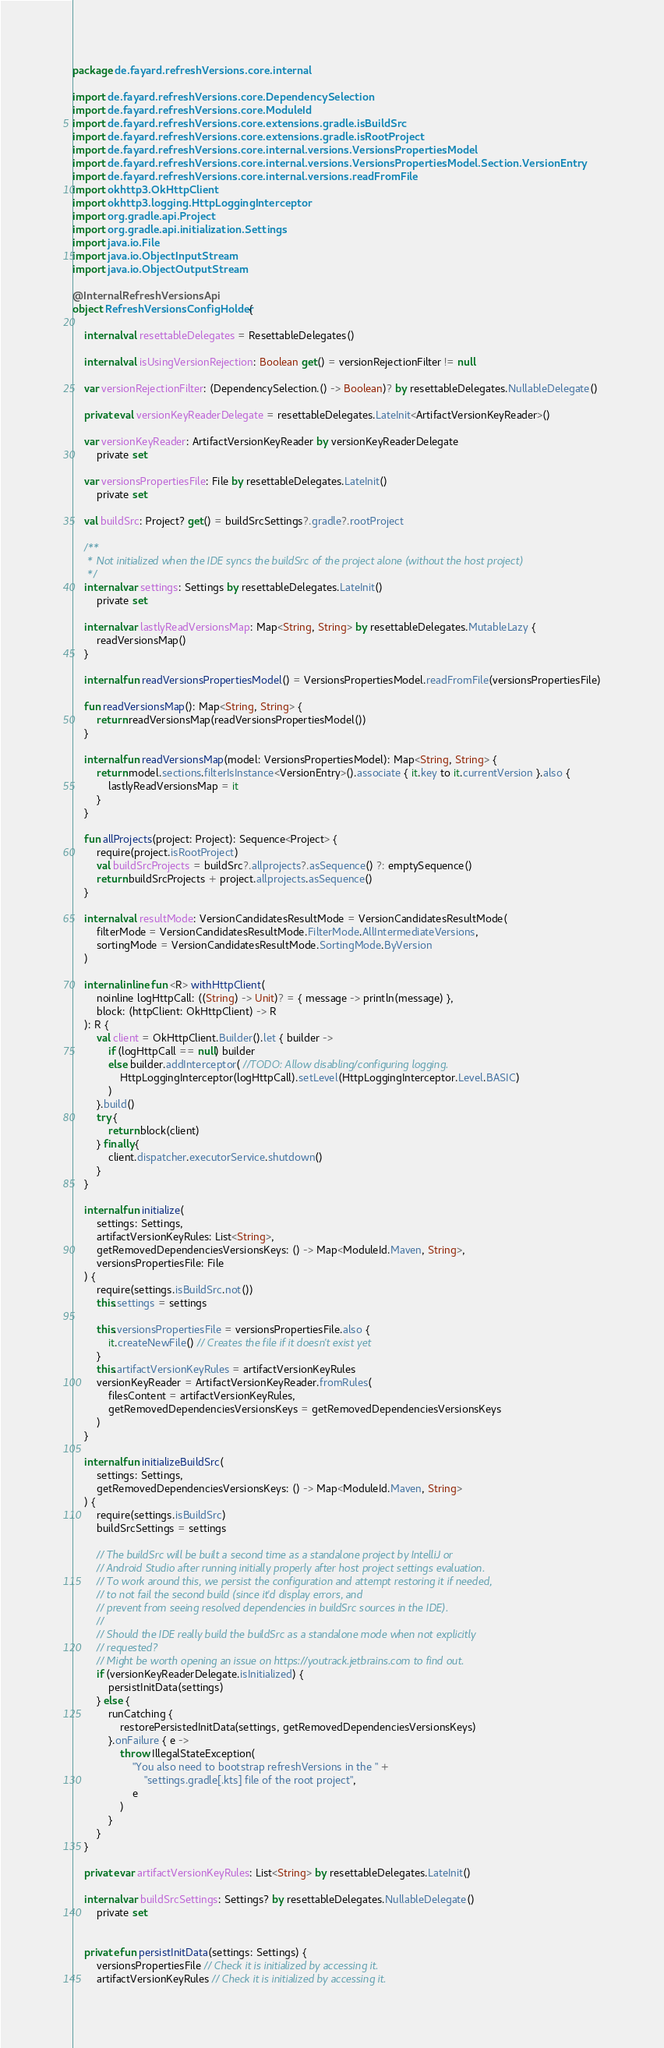<code> <loc_0><loc_0><loc_500><loc_500><_Kotlin_>package de.fayard.refreshVersions.core.internal

import de.fayard.refreshVersions.core.DependencySelection
import de.fayard.refreshVersions.core.ModuleId
import de.fayard.refreshVersions.core.extensions.gradle.isBuildSrc
import de.fayard.refreshVersions.core.extensions.gradle.isRootProject
import de.fayard.refreshVersions.core.internal.versions.VersionsPropertiesModel
import de.fayard.refreshVersions.core.internal.versions.VersionsPropertiesModel.Section.VersionEntry
import de.fayard.refreshVersions.core.internal.versions.readFromFile
import okhttp3.OkHttpClient
import okhttp3.logging.HttpLoggingInterceptor
import org.gradle.api.Project
import org.gradle.api.initialization.Settings
import java.io.File
import java.io.ObjectInputStream
import java.io.ObjectOutputStream

@InternalRefreshVersionsApi
object RefreshVersionsConfigHolder {

    internal val resettableDelegates = ResettableDelegates()

    internal val isUsingVersionRejection: Boolean get() = versionRejectionFilter != null

    var versionRejectionFilter: (DependencySelection.() -> Boolean)? by resettableDelegates.NullableDelegate()

    private val versionKeyReaderDelegate = resettableDelegates.LateInit<ArtifactVersionKeyReader>()

    var versionKeyReader: ArtifactVersionKeyReader by versionKeyReaderDelegate
        private set

    var versionsPropertiesFile: File by resettableDelegates.LateInit()
        private set

    val buildSrc: Project? get() = buildSrcSettings?.gradle?.rootProject

    /**
     * Not initialized when the IDE syncs the buildSrc of the project alone (without the host project)
     */
    internal var settings: Settings by resettableDelegates.LateInit()
        private set

    internal var lastlyReadVersionsMap: Map<String, String> by resettableDelegates.MutableLazy {
        readVersionsMap()
    }

    internal fun readVersionsPropertiesModel() = VersionsPropertiesModel.readFromFile(versionsPropertiesFile)

    fun readVersionsMap(): Map<String, String> {
        return readVersionsMap(readVersionsPropertiesModel())
    }

    internal fun readVersionsMap(model: VersionsPropertiesModel): Map<String, String> {
        return model.sections.filterIsInstance<VersionEntry>().associate { it.key to it.currentVersion }.also {
            lastlyReadVersionsMap = it
        }
    }

    fun allProjects(project: Project): Sequence<Project> {
        require(project.isRootProject)
        val buildSrcProjects = buildSrc?.allprojects?.asSequence() ?: emptySequence()
        return buildSrcProjects + project.allprojects.asSequence()
    }

    internal val resultMode: VersionCandidatesResultMode = VersionCandidatesResultMode(
        filterMode = VersionCandidatesResultMode.FilterMode.AllIntermediateVersions,
        sortingMode = VersionCandidatesResultMode.SortingMode.ByVersion
    )

    internal inline fun <R> withHttpClient(
        noinline logHttpCall: ((String) -> Unit)? = { message -> println(message) },
        block: (httpClient: OkHttpClient) -> R
    ): R {
        val client = OkHttpClient.Builder().let { builder ->
            if (logHttpCall == null) builder
            else builder.addInterceptor( //TODO: Allow disabling/configuring logging.
                HttpLoggingInterceptor(logHttpCall).setLevel(HttpLoggingInterceptor.Level.BASIC)
            )
        }.build()
        try {
            return block(client)
        } finally {
            client.dispatcher.executorService.shutdown()
        }
    }

    internal fun initialize(
        settings: Settings,
        artifactVersionKeyRules: List<String>,
        getRemovedDependenciesVersionsKeys: () -> Map<ModuleId.Maven, String>,
        versionsPropertiesFile: File
    ) {
        require(settings.isBuildSrc.not())
        this.settings = settings

        this.versionsPropertiesFile = versionsPropertiesFile.also {
            it.createNewFile() // Creates the file if it doesn't exist yet
        }
        this.artifactVersionKeyRules = artifactVersionKeyRules
        versionKeyReader = ArtifactVersionKeyReader.fromRules(
            filesContent = artifactVersionKeyRules,
            getRemovedDependenciesVersionsKeys = getRemovedDependenciesVersionsKeys
        )
    }

    internal fun initializeBuildSrc(
        settings: Settings,
        getRemovedDependenciesVersionsKeys: () -> Map<ModuleId.Maven, String>
    ) {
        require(settings.isBuildSrc)
        buildSrcSettings = settings

        // The buildSrc will be built a second time as a standalone project by IntelliJ or
        // Android Studio after running initially properly after host project settings evaluation.
        // To work around this, we persist the configuration and attempt restoring it if needed,
        // to not fail the second build (since it'd display errors, and
        // prevent from seeing resolved dependencies in buildSrc sources in the IDE).
        //
        // Should the IDE really build the buildSrc as a standalone mode when not explicitly
        // requested?
        // Might be worth opening an issue on https://youtrack.jetbrains.com to find out.
        if (versionKeyReaderDelegate.isInitialized) {
            persistInitData(settings)
        } else {
            runCatching {
                restorePersistedInitData(settings, getRemovedDependenciesVersionsKeys)
            }.onFailure { e ->
                throw IllegalStateException(
                    "You also need to bootstrap refreshVersions in the " +
                        "settings.gradle[.kts] file of the root project",
                    e
                )
            }
        }
    }

    private var artifactVersionKeyRules: List<String> by resettableDelegates.LateInit()

    internal var buildSrcSettings: Settings? by resettableDelegates.NullableDelegate()
        private set


    private fun persistInitData(settings: Settings) {
        versionsPropertiesFile // Check it is initialized by accessing it.
        artifactVersionKeyRules // Check it is initialized by accessing it.</code> 